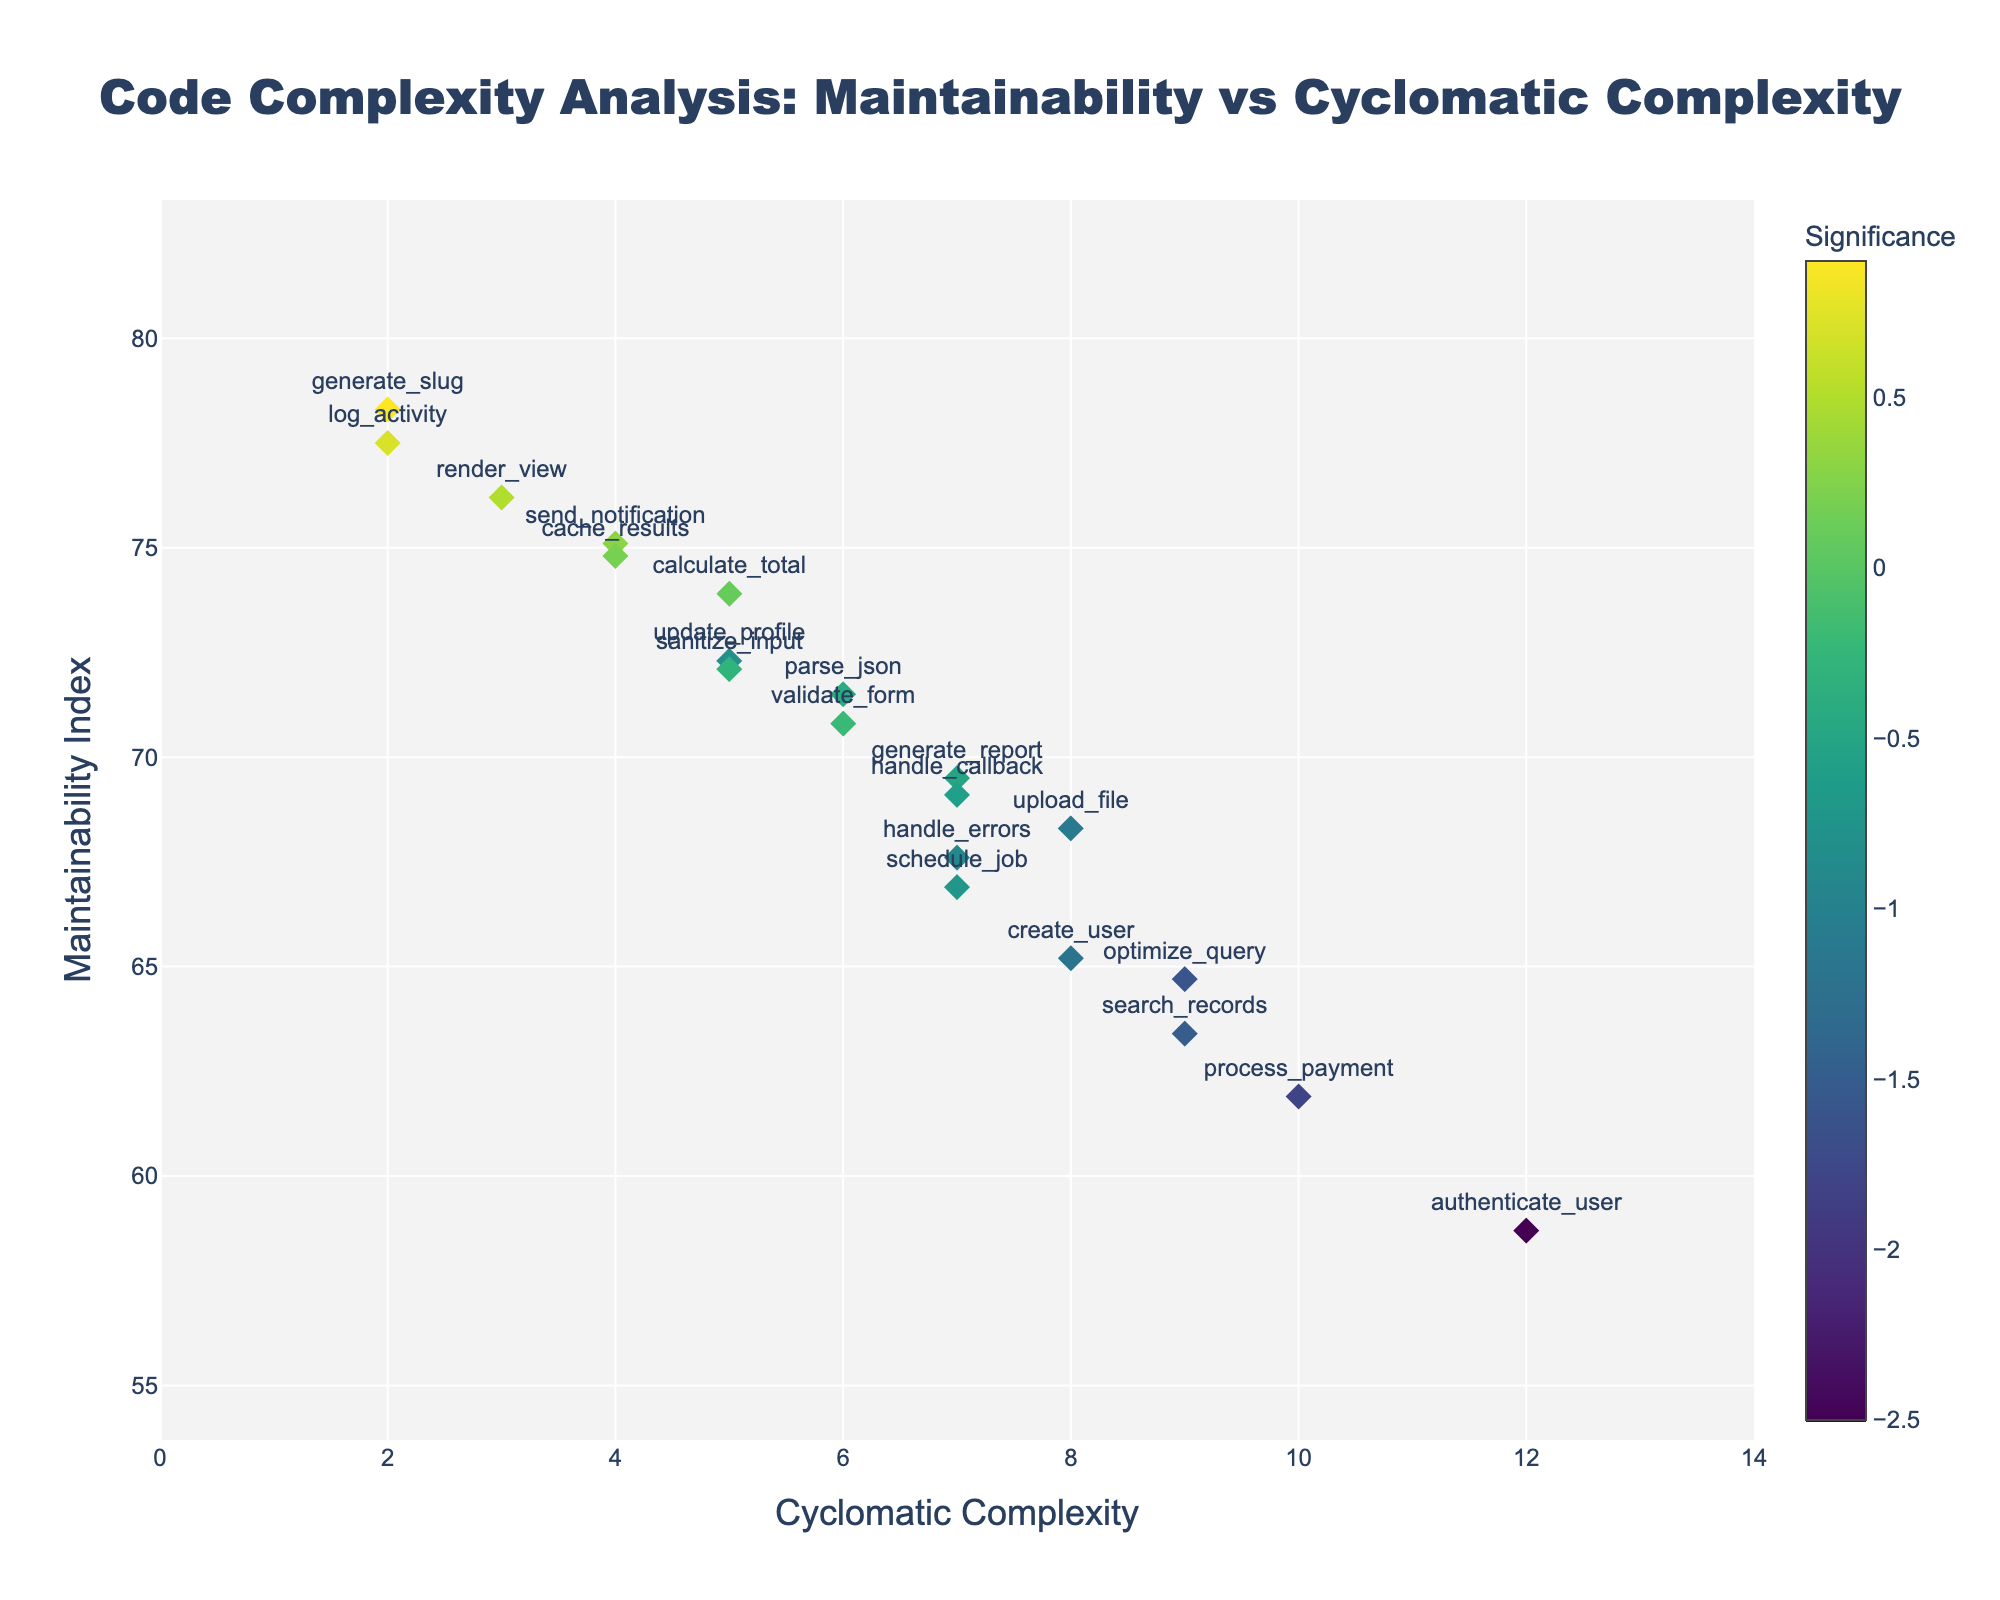What's the title of the figure? The title of a figure is usually displayed prominently at the top. In this case, it is specified in the code under the layout’s title property.
Answer: Code Complexity Analysis: Maintainability vs Cyclomatic Complexity What's shown on the x-axis and y-axis? The labels for the x-axis and y-axis often give details about what data points are being plotted. Here, they are defined in the code under xaxis_title and yaxis_title.
Answer: Cyclomatic Complexity and Maintainability Index How many methods have a cyclomatic complexity of 7? By counting the data points on the figure that align with a cyclomatic complexity value of 7 on the x-axis, we can identify the number of such methods.
Answer: 4 Which method has the highest maintainability index? The data point highest on the y-axis corresponds to the method with the highest maintainability index.
Answer: generate_slug Which method has the highest cyclomatic complexity? The data point farthest to the right on the x-axis indicates the method with the highest cyclomatic complexity.
Answer: authenticate_user For which methods are the maintainability index less than 65 and cyclomatic complexity greater than 8? We look for data points below the 65 mark on the y-axis and to the right of the 8 mark on the x-axis.
Answer: authenticate_user, process_payment, search_records, optimize_query How does maintainability index change with cyclomatic complexity? By observing the overall trend of the data points, we can infer the relationship. In this case, data points typically lower in maintainability index as cyclomatic complexity increases.
Answer: Generally decreases Which method has the smallest significance value? The color of the data points represents the significance values, with the color bar to the side indicating the value of each color. The lightest color corresponds to the smallest value.
Answer: authenticate_user 